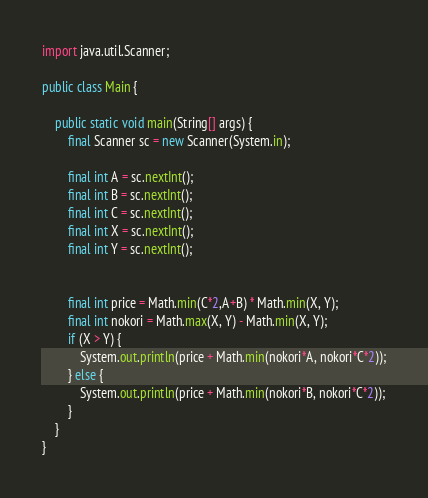Convert code to text. <code><loc_0><loc_0><loc_500><loc_500><_Java_>import java.util.Scanner;

public class Main {

    public static void main(String[] args) {
        final Scanner sc = new Scanner(System.in);

        final int A = sc.nextInt();
        final int B = sc.nextInt();
        final int C = sc.nextInt();
        final int X = sc.nextInt();
        final int Y = sc.nextInt();


        final int price = Math.min(C*2,A+B) * Math.min(X, Y);
        final int nokori = Math.max(X, Y) - Math.min(X, Y);
        if (X > Y) {
            System.out.println(price + Math.min(nokori*A, nokori*C*2));
        } else {
            System.out.println(price + Math.min(nokori*B, nokori*C*2));
        }
    }
}
</code> 